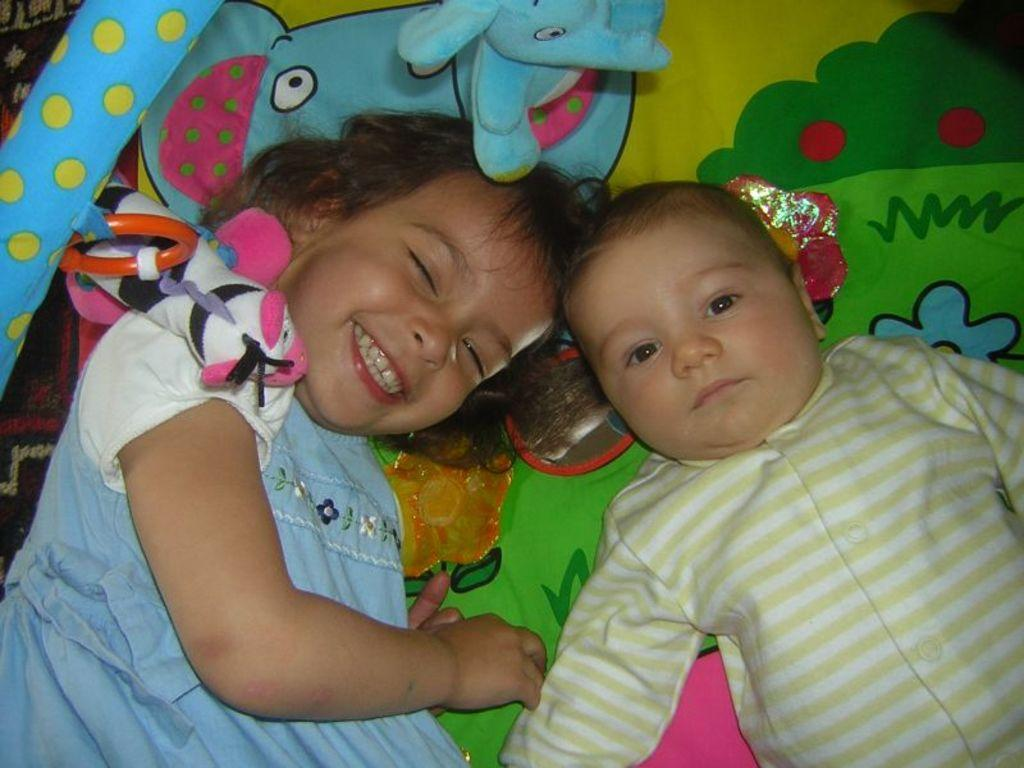How many kids are in the image? There are two kids in the image. What are the kids doing in the image? The kids are lying on a bed. What else can be seen in the image besides the kids? There is a soft toy in the image. How does the girl appear in the image? The girl is smiling. What type of calculator is the boy holding in the image? There is no calculator present in the image; it features two kids lying on a bed with a soft toy. Can you tell me how many grapes the girl is holding in the image? There are no grapes present in the image. 